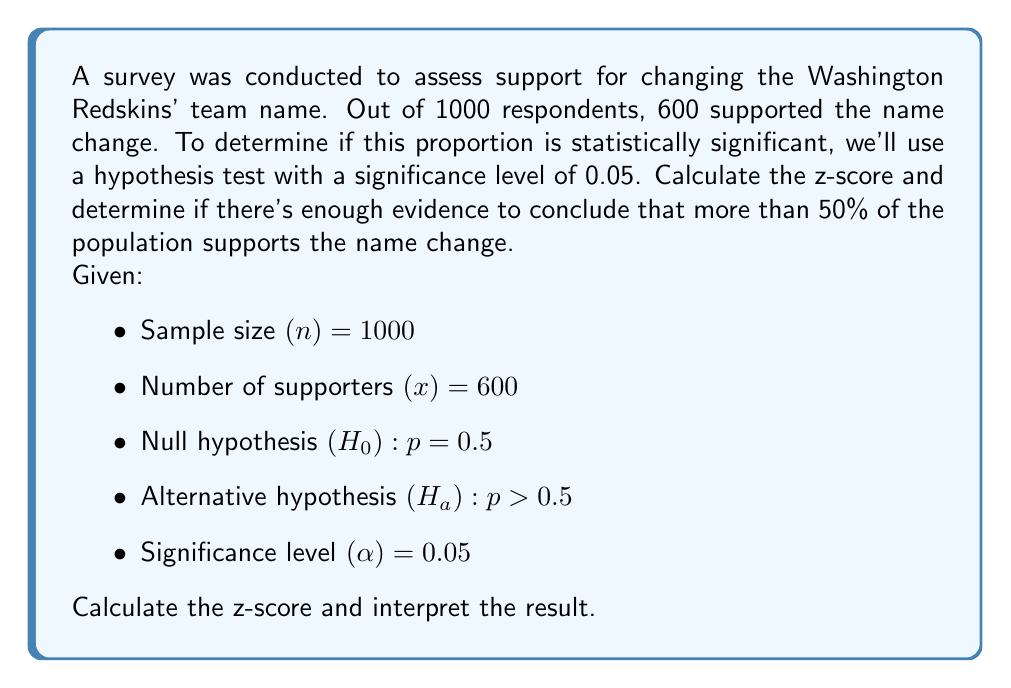Help me with this question. To solve this problem, we'll follow these steps:

1) Calculate the sample proportion:
   $\hat{p} = \frac{x}{n} = \frac{600}{1000} = 0.6$

2) Calculate the standard error:
   $SE = \sqrt{\frac{p_0(1-p_0)}{n}} = \sqrt{\frac{0.5(1-0.5)}{1000}} = \sqrt{\frac{0.25}{1000}} = 0.0158$

3) Calculate the z-score:
   $z = \frac{\hat{p} - p_0}{SE} = \frac{0.6 - 0.5}{0.0158} = 6.33$

4) Find the critical value:
   For a one-tailed test with α = 0.05, the critical z-value is 1.645.

5) Compare the calculated z-score to the critical value:
   6.33 > 1.645

6) Interpret the result:
   Since the calculated z-score (6.33) is greater than the critical value (1.645), we reject the null hypothesis.

Therefore, there is statistically significant evidence to conclude that more than 50% of the population supports changing the Washington Redskins' team name.
Answer: z = 6.33; Reject $H_0$ 